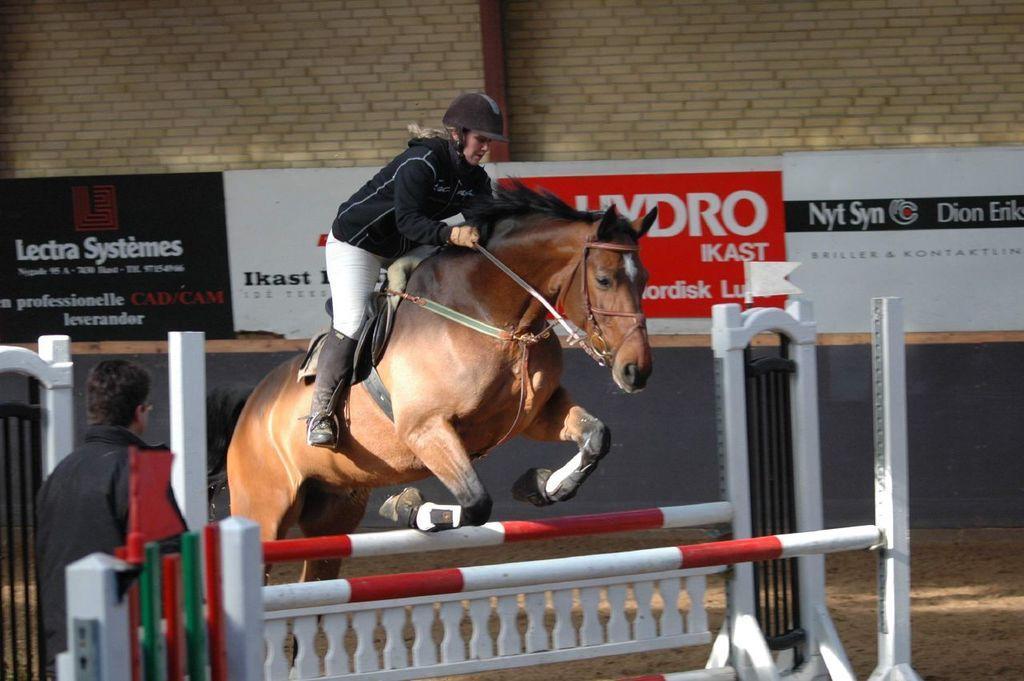Describe this image in one or two sentences. This is the woman sitting on the horse and riding. I can see another person standing here. This looks like a horse training. These are the rods. At background I can see banners. 